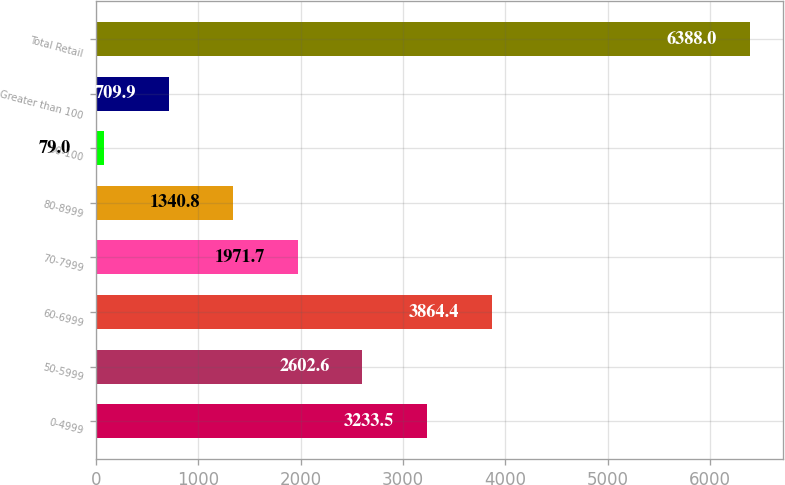<chart> <loc_0><loc_0><loc_500><loc_500><bar_chart><fcel>0-4999<fcel>50-5999<fcel>60-6999<fcel>70-7999<fcel>80-8999<fcel>90-100<fcel>Greater than 100<fcel>Total Retail<nl><fcel>3233.5<fcel>2602.6<fcel>3864.4<fcel>1971.7<fcel>1340.8<fcel>79<fcel>709.9<fcel>6388<nl></chart> 